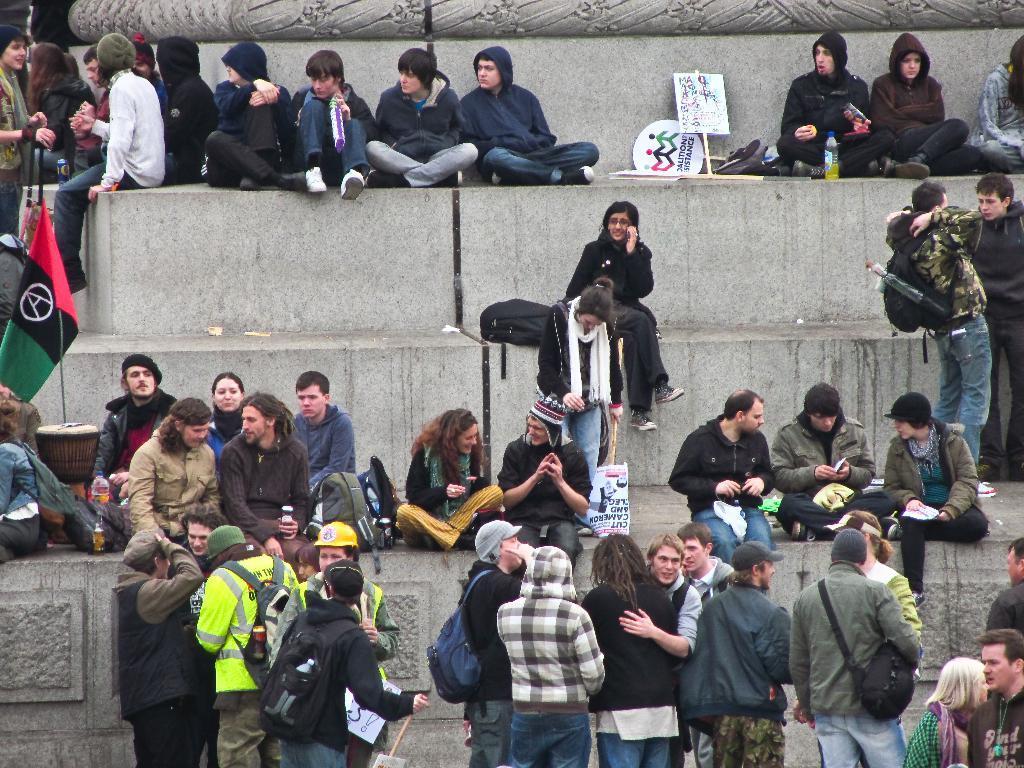In one or two sentences, can you explain what this image depicts? In this image we can see people sitting on the stairs and some of them are standing. We can see boards and bottles. There are bags and we can see a flag. 